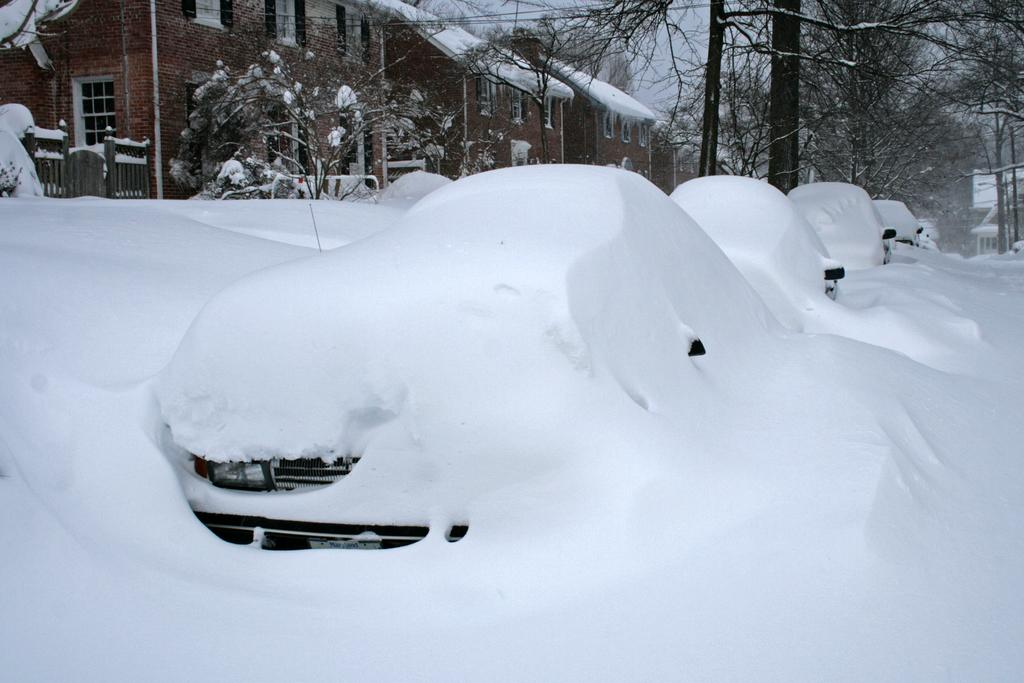What type of vehicles can be seen in the image? There are cars in the image. How is the appearance of the cars affected by the weather? The cars are covered with snow. What can be seen on the left side of the image? There are trees and buildings on the left side of the image. What type of eggs are being used to decorate the cars in the image? There are no eggs present in the image, and the cars are not being decorated with any eggs. 